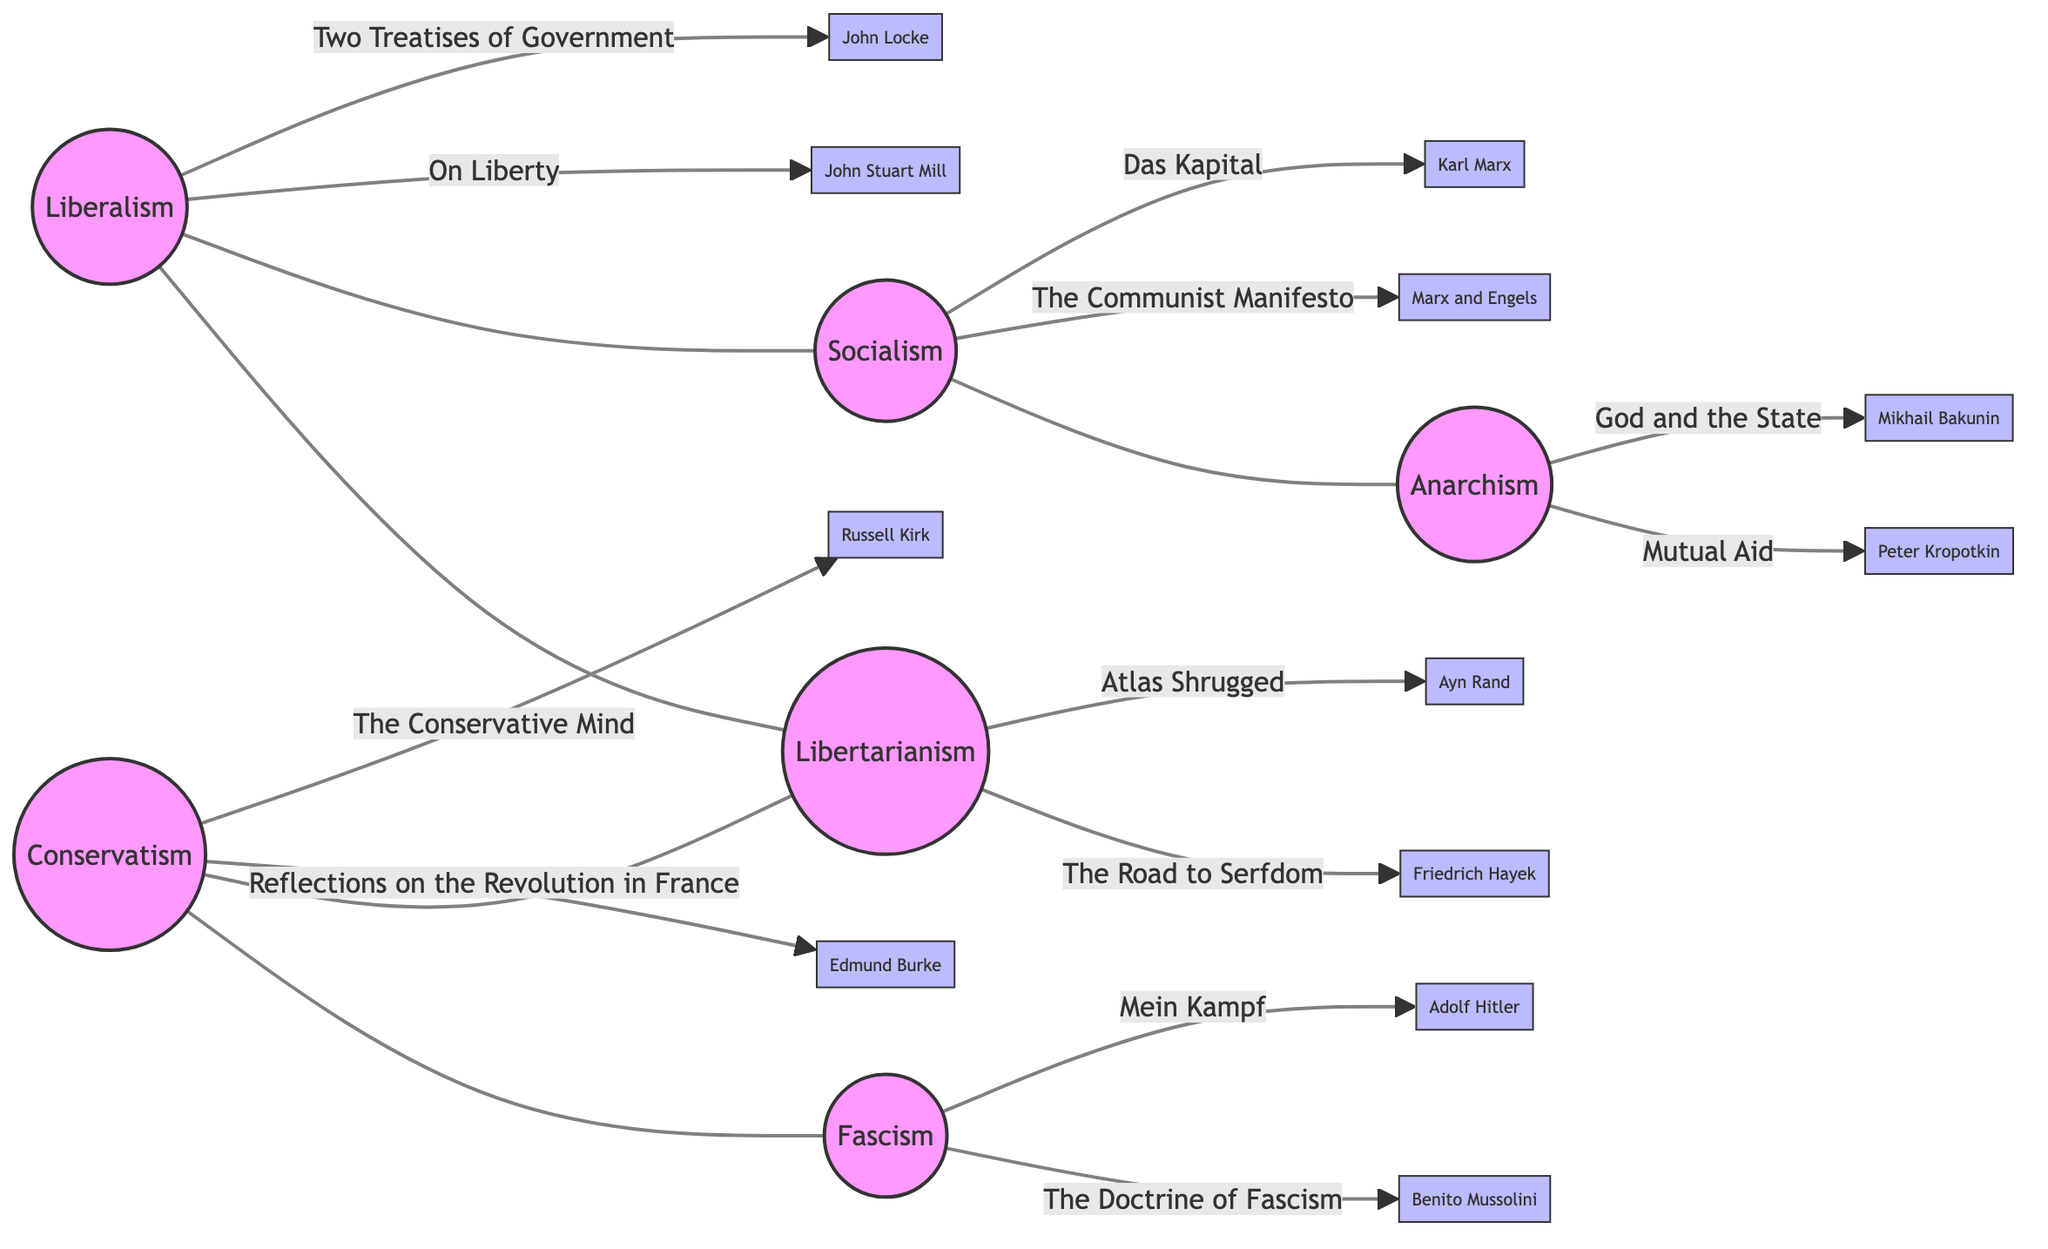What are the two major works associated with Liberalism? The diagram lists "On Liberty by John Stuart Mill" and "Two Treatises of Government by John Locke" under the node for Liberalism.
Answer: On Liberty, Two Treatises of Government Which two ideologies are connected by a relationship? The edges in the diagram show connections between ideologies. For example, Liberalism is connected to Libertarianism and Socialism.
Answer: Liberalism, Libertarianism How many total ideologies are represented in the diagram? By counting the nodes in the diagram, there are six ideologies represented: Liberalism, Conservatism, Socialism, Fascism, Anarchism, and Libertarianism.
Answer: 6 Which ideology is linked to both Socialism and Libertarianism? The connections from the diagram show that Liberalism is linked to both Socialism and Libertarianism through edges.
Answer: Liberalism What is one major work associated with Fascism? The diagram indicates "The Doctrine of Fascism by Benito Mussolini" and "Mein Kampf by Adolf Hitler" as major works associated with the Fascism node.
Answer: The Doctrine of Fascism Name one of the major works related to Anarchism. There are two works listed: "Mutual Aid by Peter Kropotkin" and "God and the State by Mikhail Bakunin". Either could be stated as the answer.
Answer: Mutual Aid Which ideologies share a connection through Conservatism? The edges show that Conservatism is connected to both Fascism and Libertarianism.
Answer: Fascism, Libertarianism How many edges connect the different political ideologies? Counting the edges in the diagram illustrates that there are five connections between the ideologies.
Answer: 5 What philosophical position connects Socialism and Anarchism? The edge directly connects Socialism to Anarchism, indicating a relationship between these two ideologies as depicted in the diagram.
Answer: Socialism 